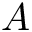Convert formula to latex. <formula><loc_0><loc_0><loc_500><loc_500>A</formula> 